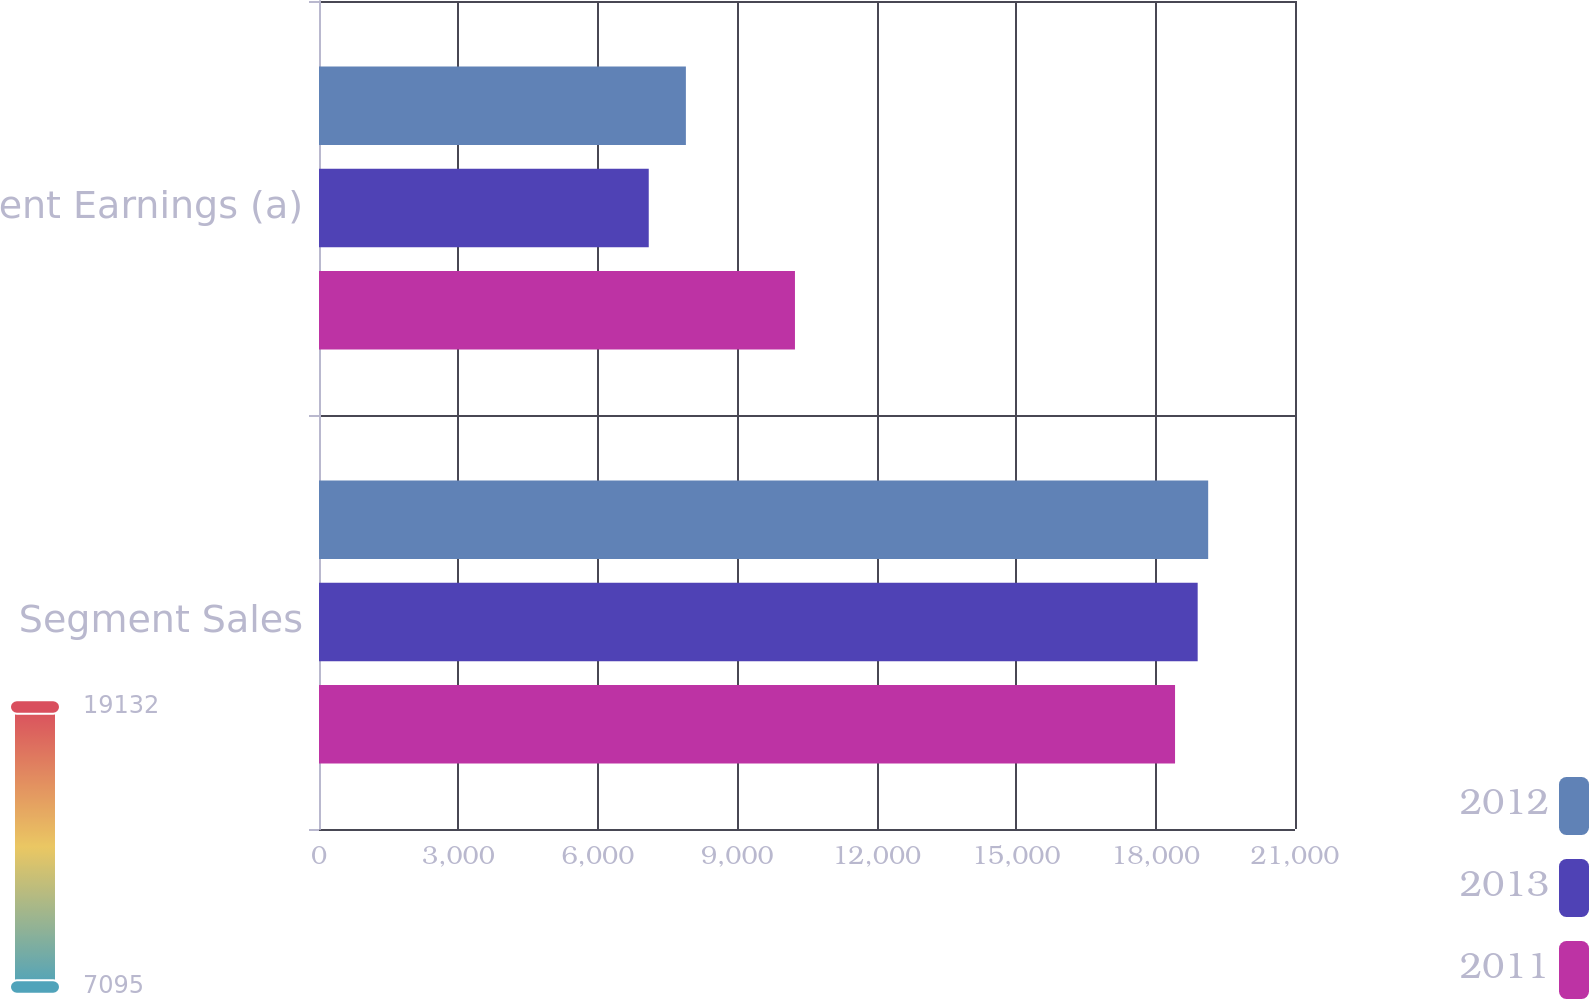Convert chart. <chart><loc_0><loc_0><loc_500><loc_500><stacked_bar_chart><ecel><fcel>Segment Sales<fcel>Segment Earnings (a)<nl><fcel>2012<fcel>19132<fcel>7894<nl><fcel>2013<fcel>18906<fcel>7095<nl><fcel>2011<fcel>18419<fcel>10241<nl></chart> 